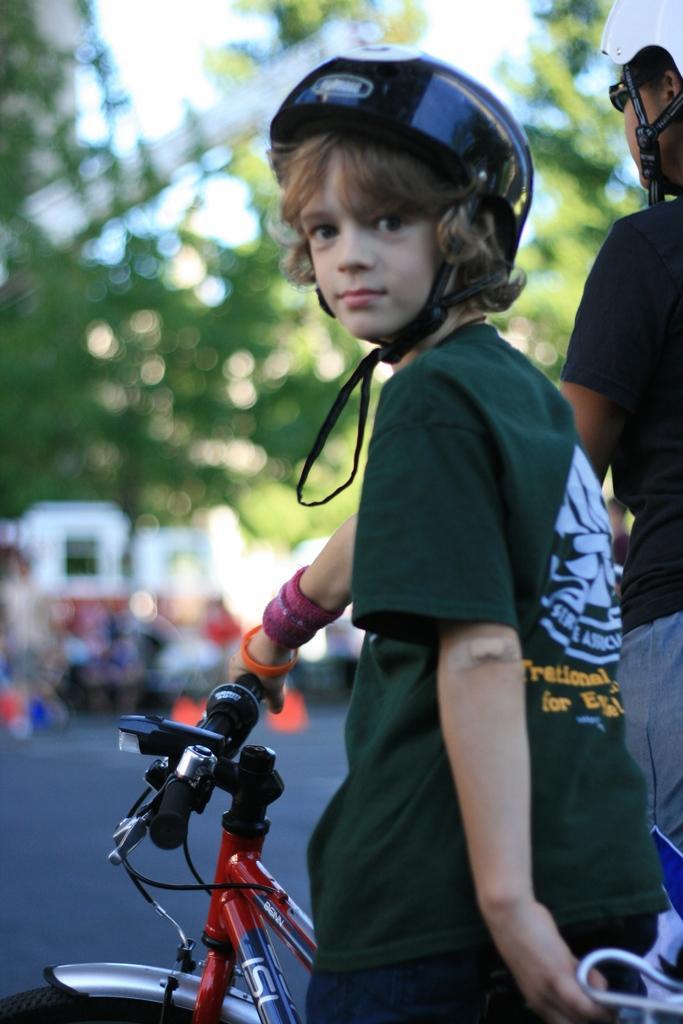How would you summarize this image in a sentence or two? In the middle of the image a boy is standing on a bicycle. Top right side of the image a person is standing. Top left side of the image there are some trees and there are some vehicles. 